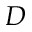Convert formula to latex. <formula><loc_0><loc_0><loc_500><loc_500>D</formula> 